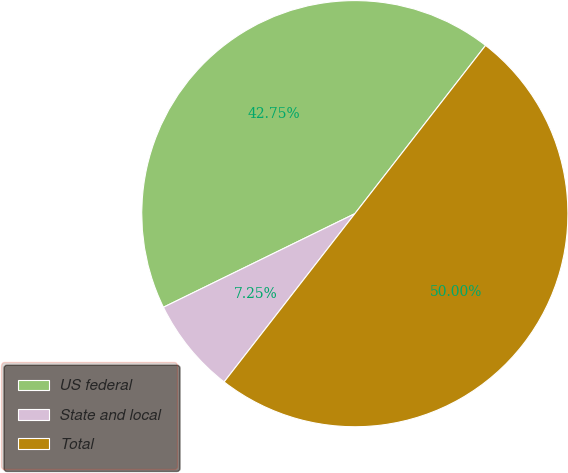<chart> <loc_0><loc_0><loc_500><loc_500><pie_chart><fcel>US federal<fcel>State and local<fcel>Total<nl><fcel>42.75%<fcel>7.25%<fcel>50.0%<nl></chart> 